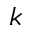Convert formula to latex. <formula><loc_0><loc_0><loc_500><loc_500>k</formula> 